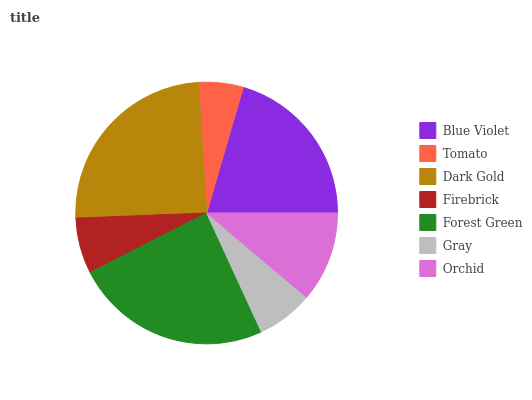Is Tomato the minimum?
Answer yes or no. Yes. Is Dark Gold the maximum?
Answer yes or no. Yes. Is Dark Gold the minimum?
Answer yes or no. No. Is Tomato the maximum?
Answer yes or no. No. Is Dark Gold greater than Tomato?
Answer yes or no. Yes. Is Tomato less than Dark Gold?
Answer yes or no. Yes. Is Tomato greater than Dark Gold?
Answer yes or no. No. Is Dark Gold less than Tomato?
Answer yes or no. No. Is Orchid the high median?
Answer yes or no. Yes. Is Orchid the low median?
Answer yes or no. Yes. Is Dark Gold the high median?
Answer yes or no. No. Is Firebrick the low median?
Answer yes or no. No. 